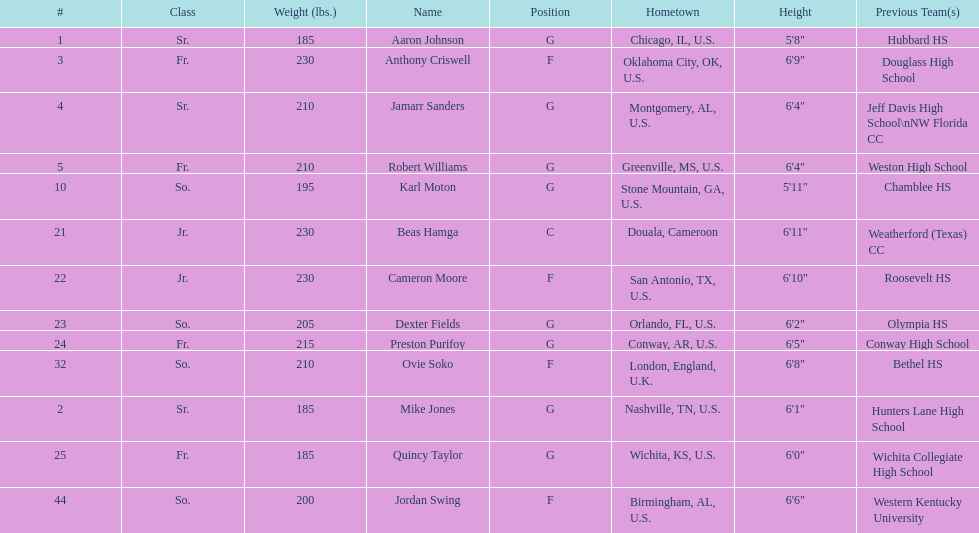Who is first on the roster? Aaron Johnson. 